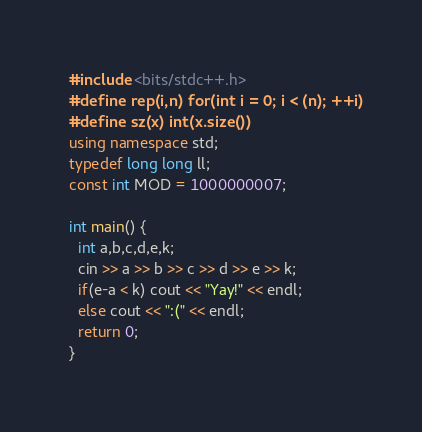<code> <loc_0><loc_0><loc_500><loc_500><_C++_>#include <bits/stdc++.h>
#define rep(i,n) for(int i = 0; i < (n); ++i)
#define sz(x) int(x.size())
using namespace std;
typedef long long ll;
const int MOD = 1000000007;

int main() {
  int a,b,c,d,e,k;
  cin >> a >> b >> c >> d >> e >> k;
  if(e-a < k) cout << "Yay!" << endl;
  else cout << ":(" << endl;
  return 0;
}</code> 